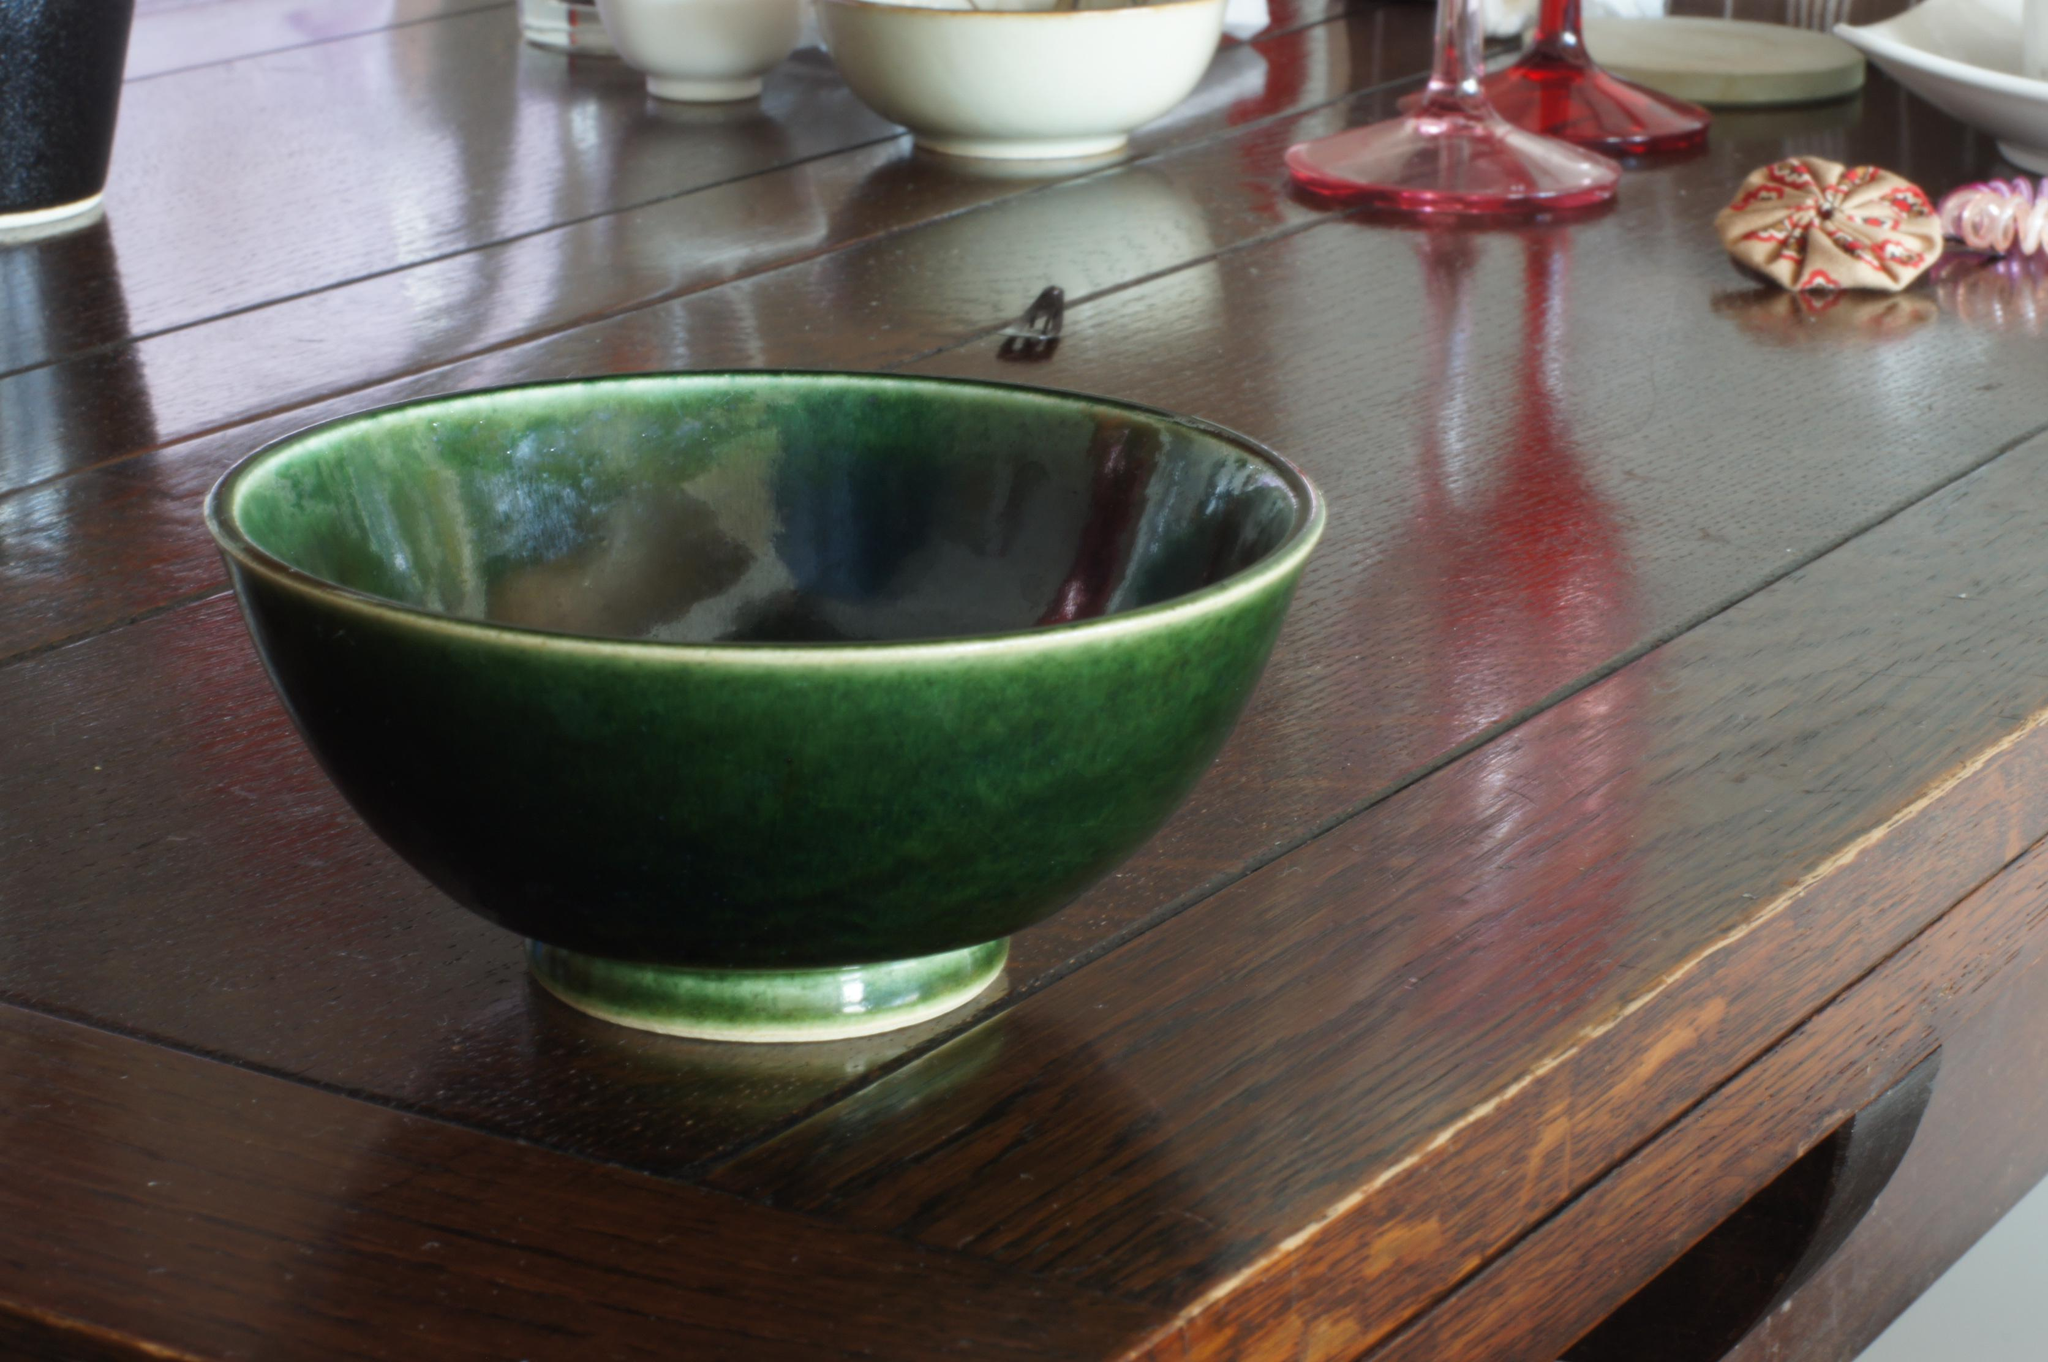What type of furniture is present in the image? There is a table in the image. What objects are placed on the table? There are bowls and glasses on the table. What type of rock can be seen on the table in the image? There is no rock present on the table in the image. What type of offer is being made with the items on the table in the image? There is no offer being made in the image; it simply shows a table with bowls and glasses. 